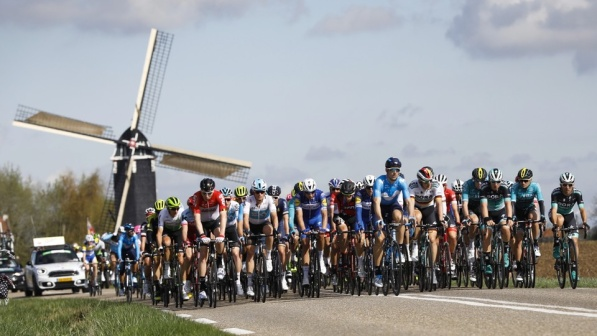Can you provide a brief overview of what is happening in this photo? The photo shows a group of cyclists riding closely together on a road, likely participating in a race or group ride. A windmill can be seen in the background, adding a touch of scenic beauty to the scene. What can you infer about the environment and weather conditions from this image? The environment appears to be rural and open, evident from the visible stretch of road, grassy surroundings, and the windmill. The weather conditions seem clear and pleasant, as indicated by the blue sky and scattered clouds. Describe the possible mood or atmosphere captured in this photo. The mood of the photo is lively and energetic, attributed to the group of cyclists pedaling together. The bright colors of their jerseys and helmets suggest a spirited or competitive setting. The addition of the windmill and the pastoral surroundings contributes a sense of tranquility and beauty, creating a well-balanced, vibrant atmosphere. If you were to create a story based on this image, what would it be about? In a small European village known for its enduring charm and scenic vistas, an annual cycling race from the heart of the village to the outskirts beyond the iconic old windmill captures everyone’s imagination. Riders from different parts of the world gather, their colorful uniforms creating a lively spectacle against the rural landscape. This year, the stakes are higher— the winner will earn not just a medal, but the honor of lighting the village’s grand festival lantern, a tradition that traces back centuries. The photo captures the pivotal moment when the cyclists pass the historic windmill, each rider’s face a tableau of determination and excitement, embodying the spirit of the race and the rich history of the village. 